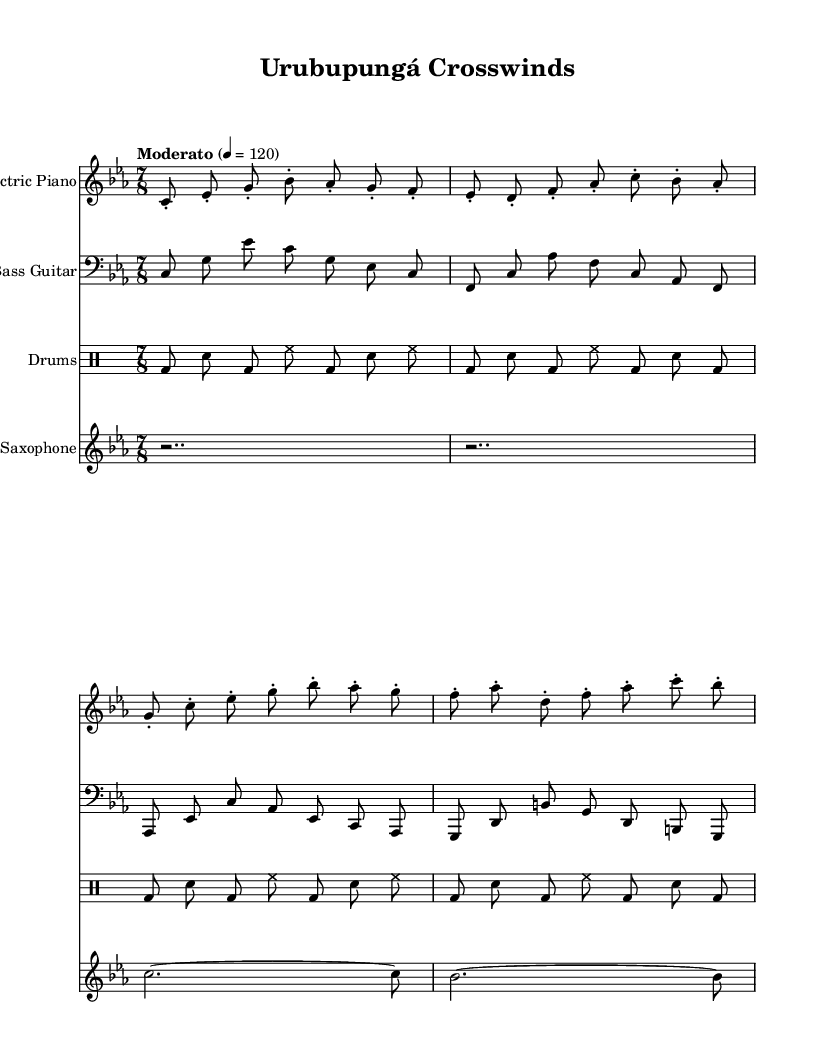What is the key signature of this music? The key signature is C minor, indicated by three flats.
Answer: C minor What is the time signature of this music? The time signature is 7/8, as indicated at the beginning of the score.
Answer: 7/8 What is the tempo marking for the piece? The tempo marking is "Moderato" set at 120 beats per minute.
Answer: Moderato How many measures are in the electric piano part? The electric piano part has four measures, as indicated by the end of each measure.
Answer: Four What is the rhythm pattern played by the drums? The drums alternate between bass drum and snare, with hi-hat maintaining the pulse.
Answer: Alternating bass and snare Which instrument plays the melody in this piece? The saxophone primarily carries the melody, indicated by the single note written in its staff.
Answer: Saxophone How does the bass guitar contribute to the jazz fusion style? The bass guitar provides a syncopated groove that complements the complex rhythms of the drums.
Answer: Syncopated groove 